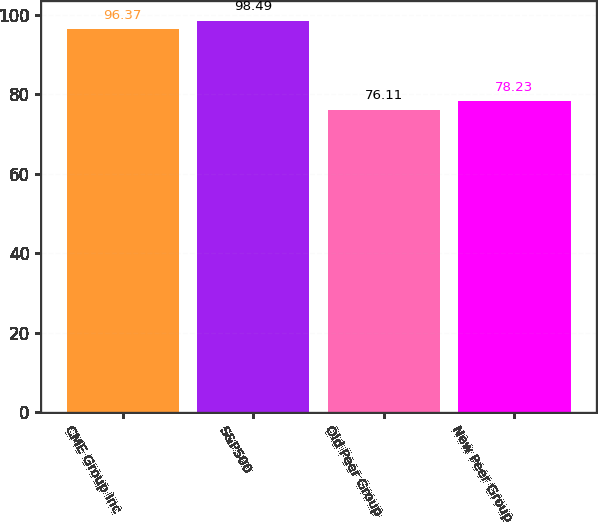<chart> <loc_0><loc_0><loc_500><loc_500><bar_chart><fcel>CME Group Inc<fcel>S&P500<fcel>Old Peer Group<fcel>New Peer Group<nl><fcel>96.37<fcel>98.49<fcel>76.11<fcel>78.23<nl></chart> 